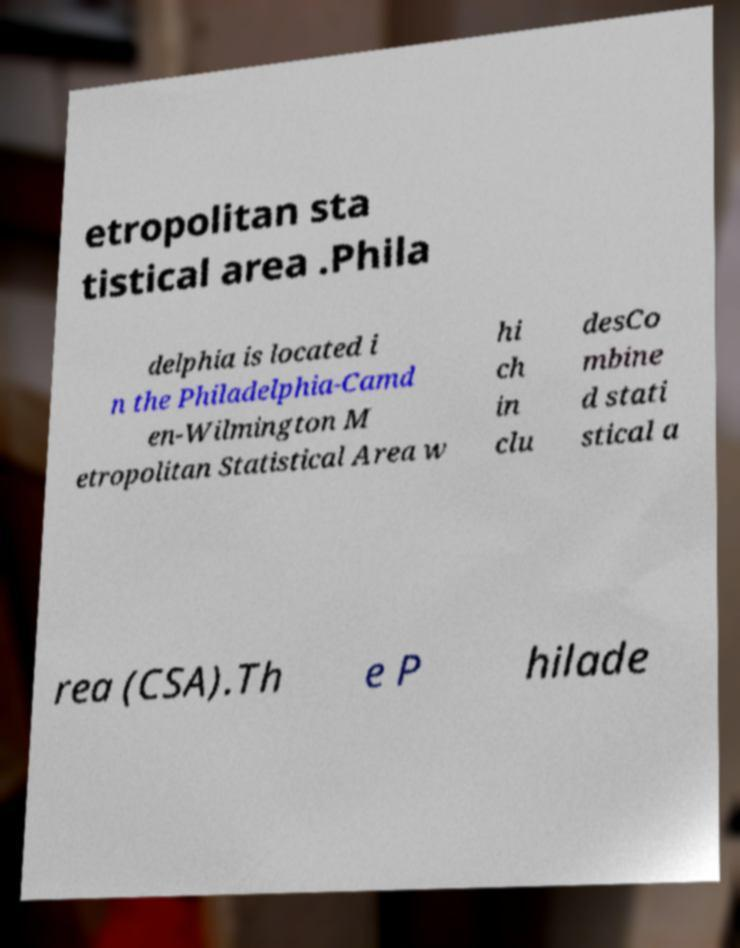What messages or text are displayed in this image? I need them in a readable, typed format. etropolitan sta tistical area .Phila delphia is located i n the Philadelphia-Camd en-Wilmington M etropolitan Statistical Area w hi ch in clu desCo mbine d stati stical a rea (CSA).Th e P hilade 